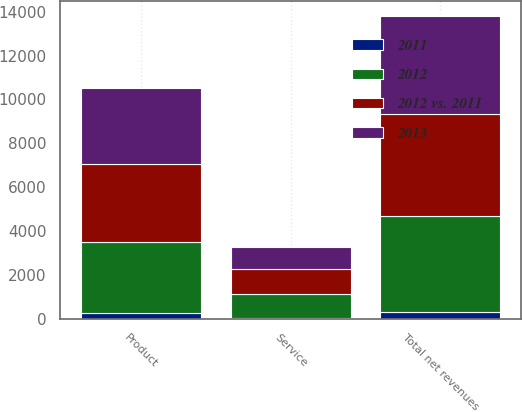<chart> <loc_0><loc_0><loc_500><loc_500><stacked_bar_chart><ecel><fcel>Product<fcel>Service<fcel>Total net revenues<nl><fcel>2012 vs. 2011<fcel>3519.9<fcel>1149.2<fcel>4669.1<nl><fcel>2012<fcel>3262.1<fcel>1103.3<fcel>4365.4<nl><fcel>2013<fcel>3478.3<fcel>970.4<fcel>4448.7<nl><fcel>2011<fcel>257.8<fcel>45.9<fcel>303.7<nl></chart> 